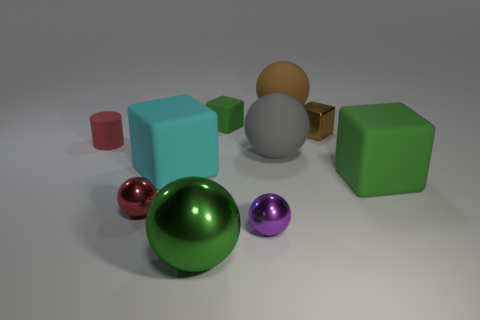What is the shape of the small matte object behind the small matte cylinder?
Give a very brief answer. Cube. What number of green objects are both behind the small rubber cylinder and in front of the small red metal object?
Offer a very short reply. 0. What number of other things are the same size as the purple thing?
Your answer should be very brief. 4. There is a large green object to the left of the gray ball; is its shape the same as the red thing that is in front of the red rubber cylinder?
Make the answer very short. Yes. How many things are small yellow metallic balls or large rubber spheres that are behind the cylinder?
Your answer should be compact. 1. What material is the cube that is on the right side of the small green matte cube and in front of the red matte cylinder?
Make the answer very short. Rubber. Is there any other thing that is the same shape as the large metal thing?
Give a very brief answer. Yes. The other big object that is made of the same material as the purple object is what color?
Ensure brevity in your answer.  Green. What number of things are either small matte objects or large brown shiny balls?
Provide a succinct answer. 2. There is a purple metallic ball; does it have the same size as the ball behind the small green rubber object?
Provide a succinct answer. No. 